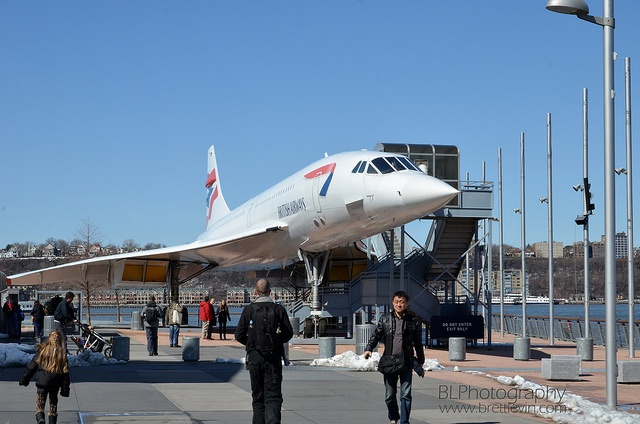Describe the objects in this image and their specific colors. I can see airplane in gray, lightgray, black, and darkgray tones, people in gray and black tones, people in gray, black, navy, and blue tones, people in gray, black, and maroon tones, and backpack in gray, black, darkgray, and navy tones in this image. 